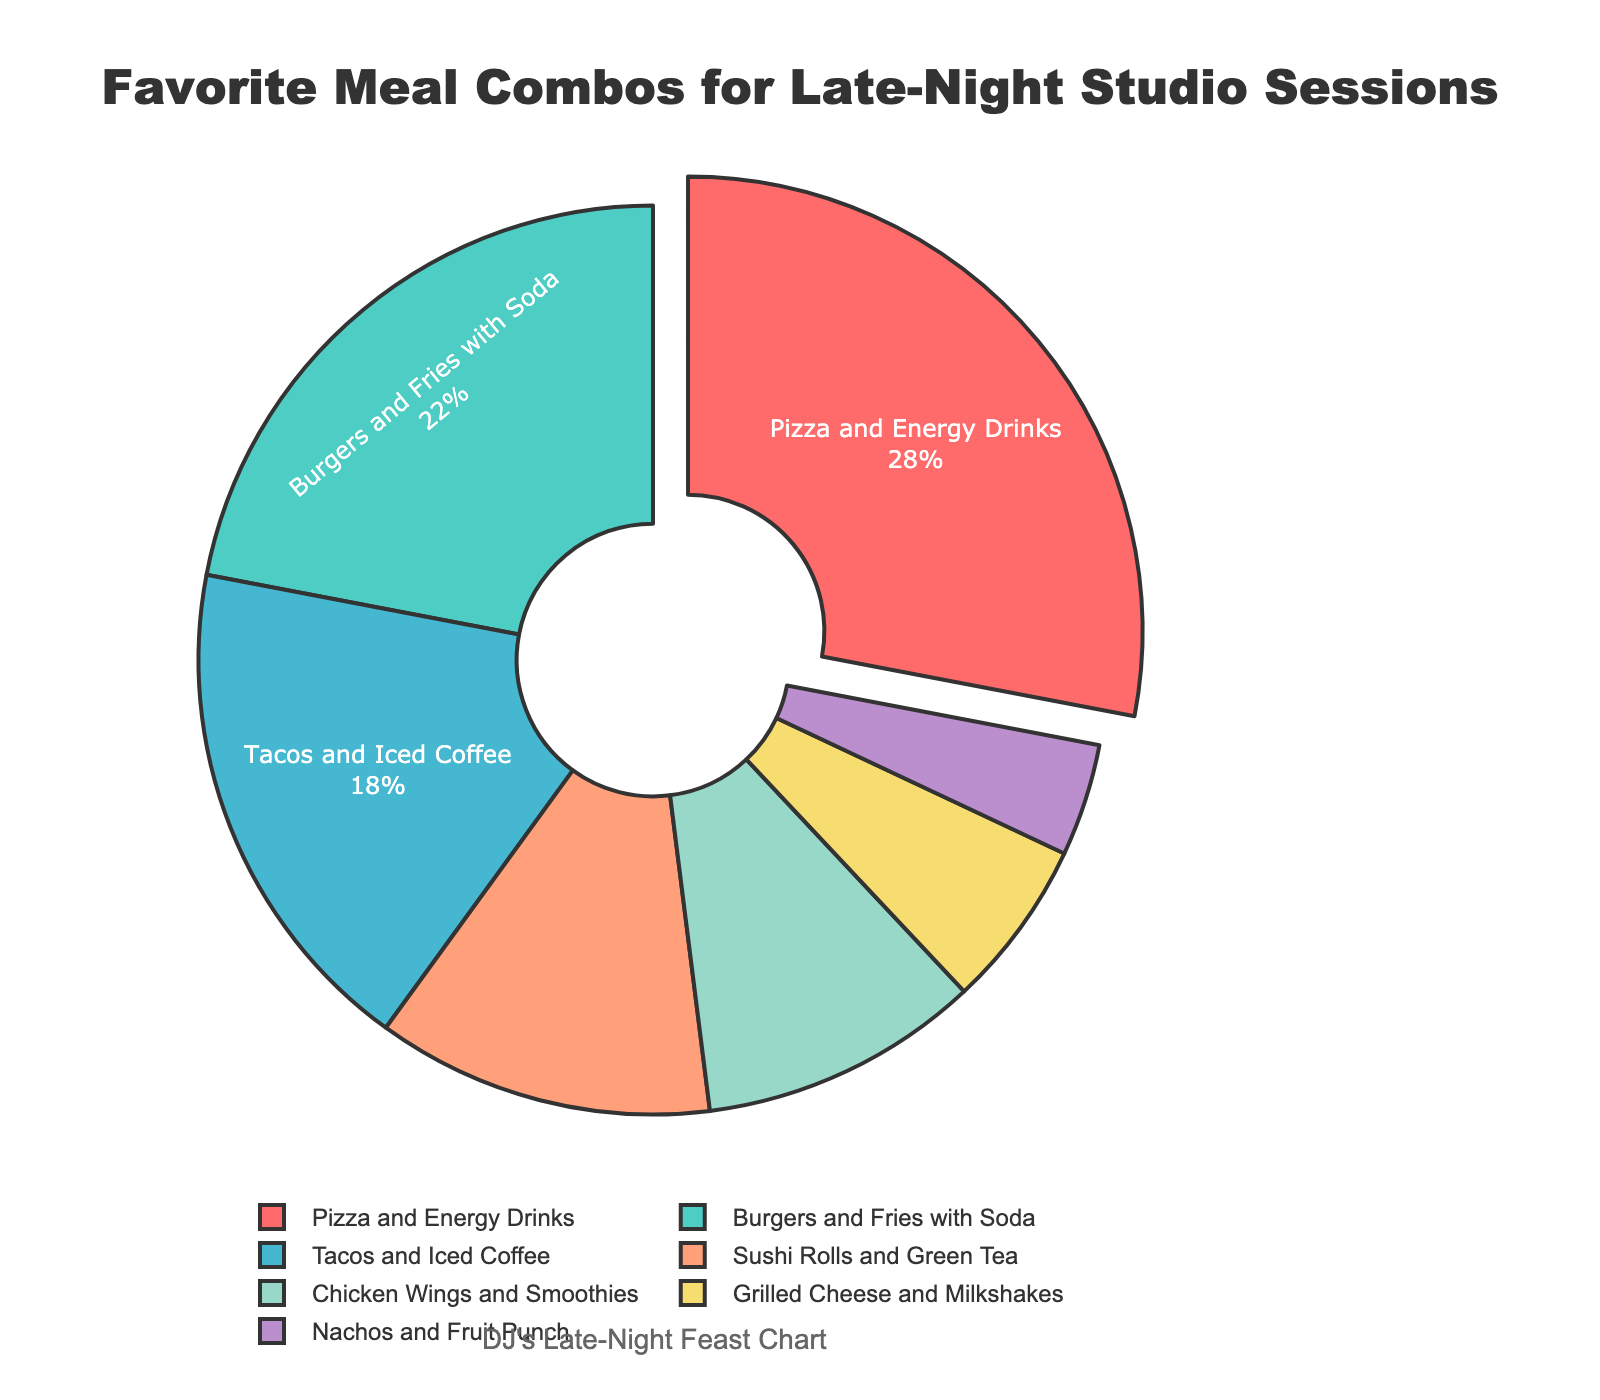Which meal combination holds the largest percentage? The largest segment shown with a pull effect is "Pizza and Energy Drinks".
Answer: Pizza and Energy Drinks Which meal combination is the least favorite? The smallest segment in the pie chart is labeled "Nachos and Fruit Punch".
Answer: Nachos and Fruit Punch What is the sum of percentages for "Burgers and Fries with Soda" and "Tacos and Iced Coffee"? The percentages for the two segments are 22% and 18%. Adding them gives 22 + 18 = 40%.
Answer: 40% How much more popular are "Pizza and Energy Drinks" compared to "Sushi Rolls and Green Tea"? The percentages are 28% and 12%, respectively. Subtracting them gives 28 - 12 = 16%.
Answer: 16% Which meal combination has a larger percentage, "Chicken Wings and Smoothies" or "Grilled Cheese and Milkshakes"? "Chicken Wings and Smoothies" is 10% while "Grilled Cheese and Milkshakes" is 6%. 10% is greater than 6%.
Answer: Chicken Wings and Smoothies What is the combined percentage of the three least favorite meal combinations? The percentages are 12% (Sushi Rolls and Green Tea), 6% (Grilled Cheese and Milkshakes), and 4% (Nachos and Fruit Punch). Summing them up gives 12 + 6 + 4 = 22%.
Answer: 22% What color represents "Burgers and Fries with Soda"? The second segment in the pie chart is light green, corresponding to "Burgers and Fries with Soda".
Answer: Light green Is "Tacos and Iced Coffee" more or less popular than "Burgers and Fries with Soda"? "Tacos and Iced Coffee" is 18% and "Burgers and Fries with Soda" is 22%. 18% is less than 22%.
Answer: Less popular What percentage of people prefer "Sushi Rolls and Green Tea" or "Grilled Cheese and Milkshakes"? The individual percentages are 12% and 6%. Adding them gives 12 + 6 = 18%.
Answer: 18% Which meal combination is represented by the light blue segment? The light blue segment corresponds to the third largest segment which is "Tacos and Iced Coffee".
Answer: Tacos and Iced Coffee 